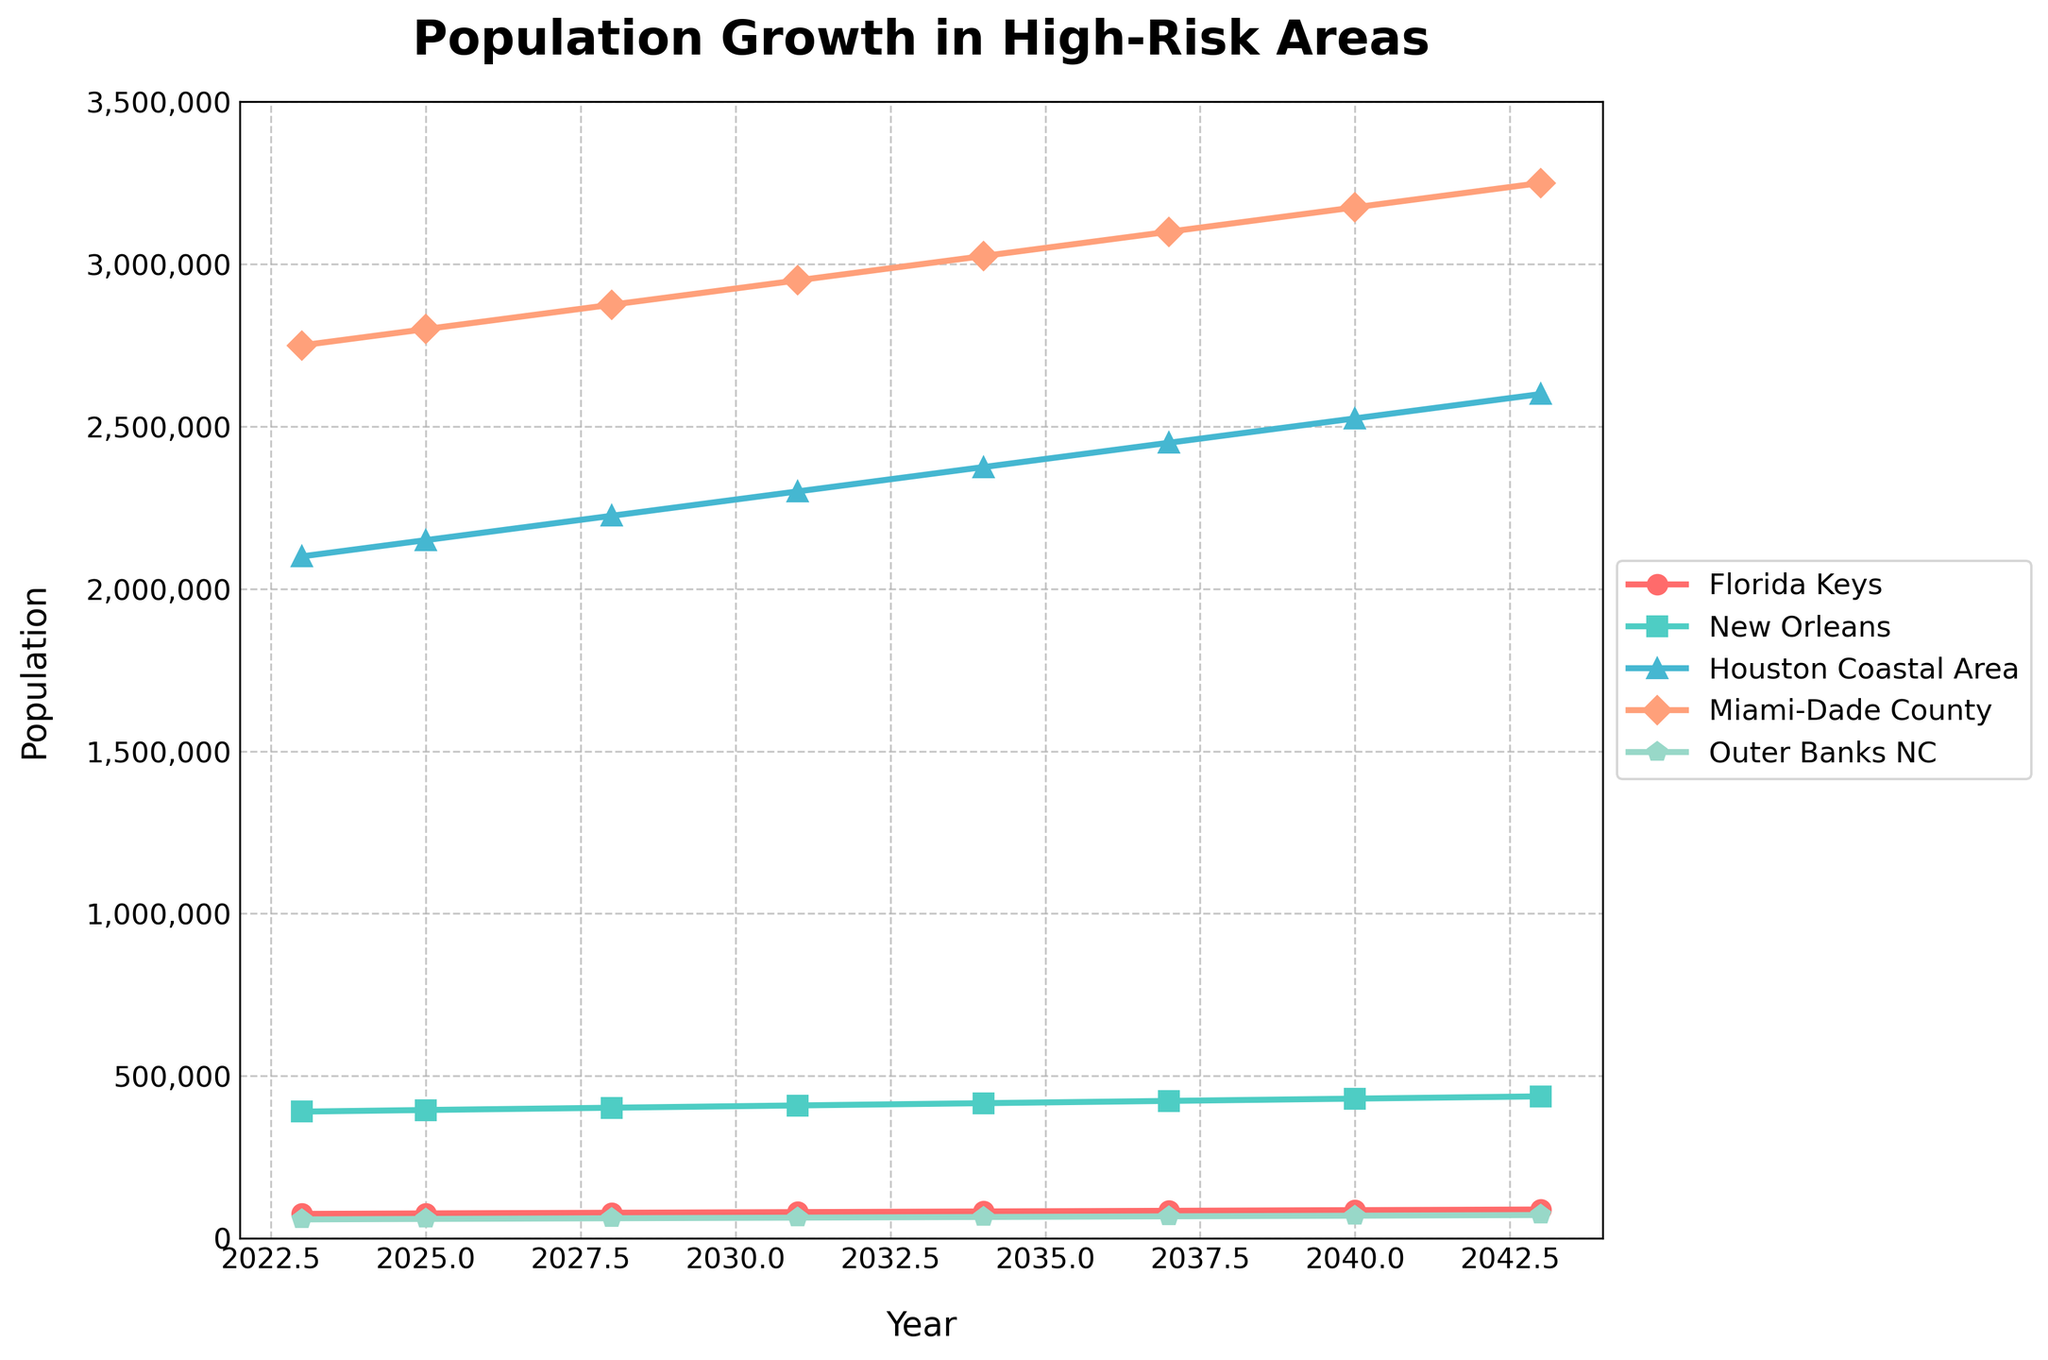What is the projected population of Miami-Dade County in 2043? Look for the year 2043 on the x-axis, follow the line for Miami-Dade County, and read the corresponding value on the y-axis.
Answer: 3,250,000 Which area shows the fastest population growth between 2023 and 2043? Compare the difference in population from 2023 to 2043 for each area by looking at the endpoints of each line. The area with the largest increase is New Orleans (from 390,000 to 437,000).
Answer: New Orleans What is the difference in the population of the Florida Keys between 2023 and 2040? Subtract the population of the Florida Keys in 2023 from its population in 2040 (86,500 - 75,000).
Answer: 11,500 What is the average population of the Outer Banks NC for the years provided? Add the population values for Outer Banks NC from 2023 to 2043 and divide by the number of years (58,000 + 59,500 + 61,500 + 63,500 + 65,500 + 67,500 + 69,500 + 71,500)/8.
Answer: 64,250 Which area has a population greater than 2,000,000 in 2023? Identify the areas on the y-axis for 2023 that have population values over 2,000,000 (Houston Coastal Area and Miami-Dade County).
Answer: Houston Coastal Area and Miami-Dade County In which year does the population of Miami-Dade County reach 3,000,000? Look for the point where the Miami-Dade County line crosses the 3,000,000 mark on the y-axis.
Answer: 2034 Comparing Houston Coastal Area and Miami-Dade County, which area has a consistently higher population throughout the years? Compare the y-axis values for Houston Coastal Area and Miami-Dade County for each year. Miami-Dade County has higher values.
Answer: Miami-Dade County What is the projected population change for New Orleans from 2023 to 2043? Subtract the 2023 population from the 2043 population for New Orleans (437,000 - 390,000).
Answer: 47,000 What color represents the population growth for Miami-Dade County in the chart? Identify the color of the line for Miami-Dade County by looking at the legend.
Answer: Orange Which year shows the smallest population in Outer Banks NC and what is the value? Find the lowest point of the line for Outer Banks NC and the corresponding year.
Answer: 2023, 58,000 